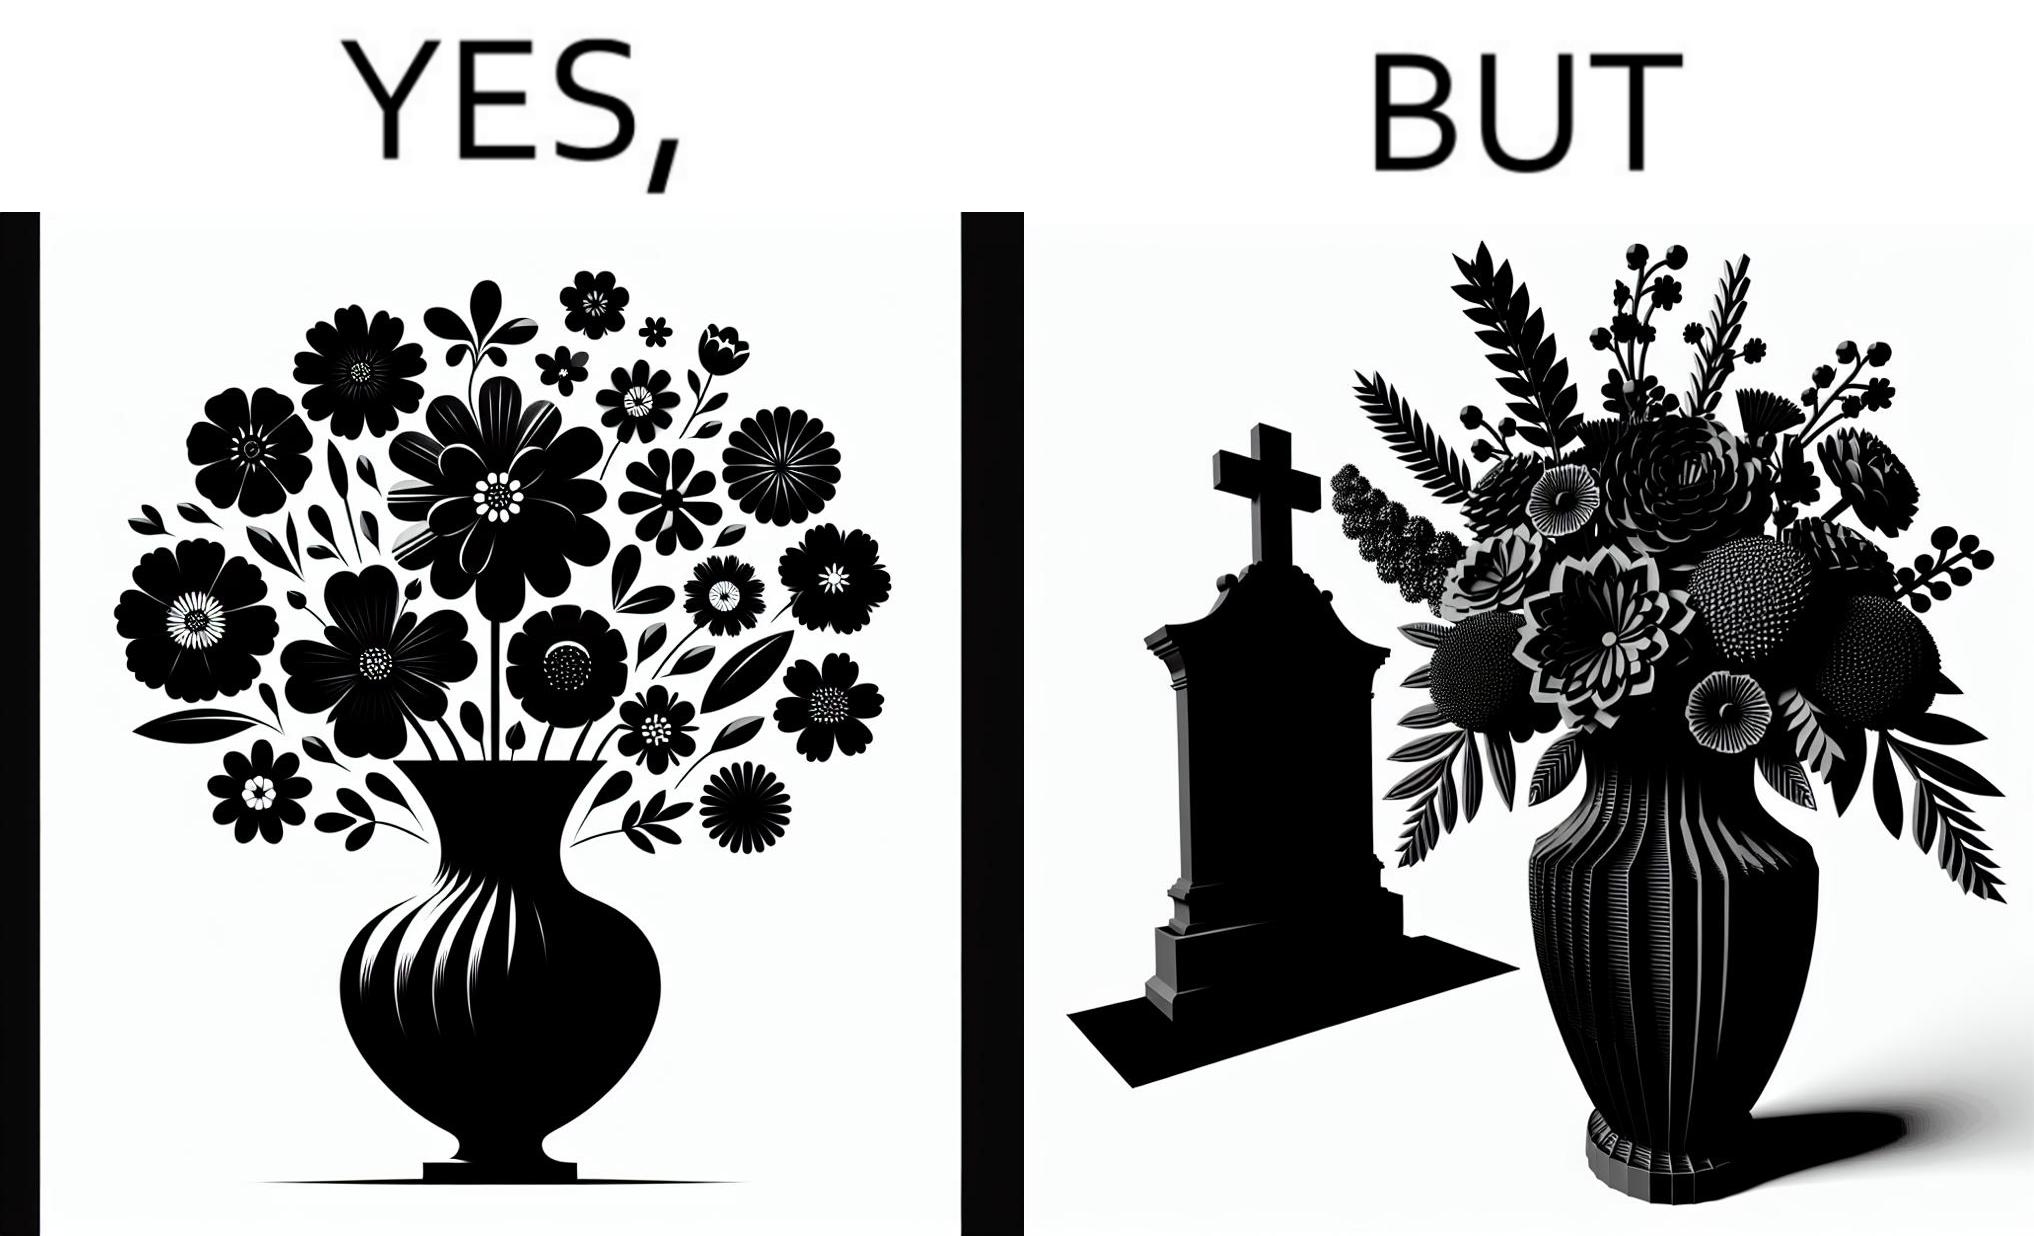Is this a satirical image? Yes, this image is satirical. 